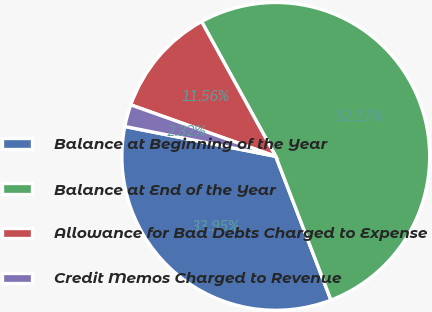<chart> <loc_0><loc_0><loc_500><loc_500><pie_chart><fcel>Balance at Beginning of the Year<fcel>Balance at End of the Year<fcel>Allowance for Bad Debts Charged to Expense<fcel>Credit Memos Charged to Revenue<nl><fcel>33.95%<fcel>52.17%<fcel>11.56%<fcel>2.32%<nl></chart> 